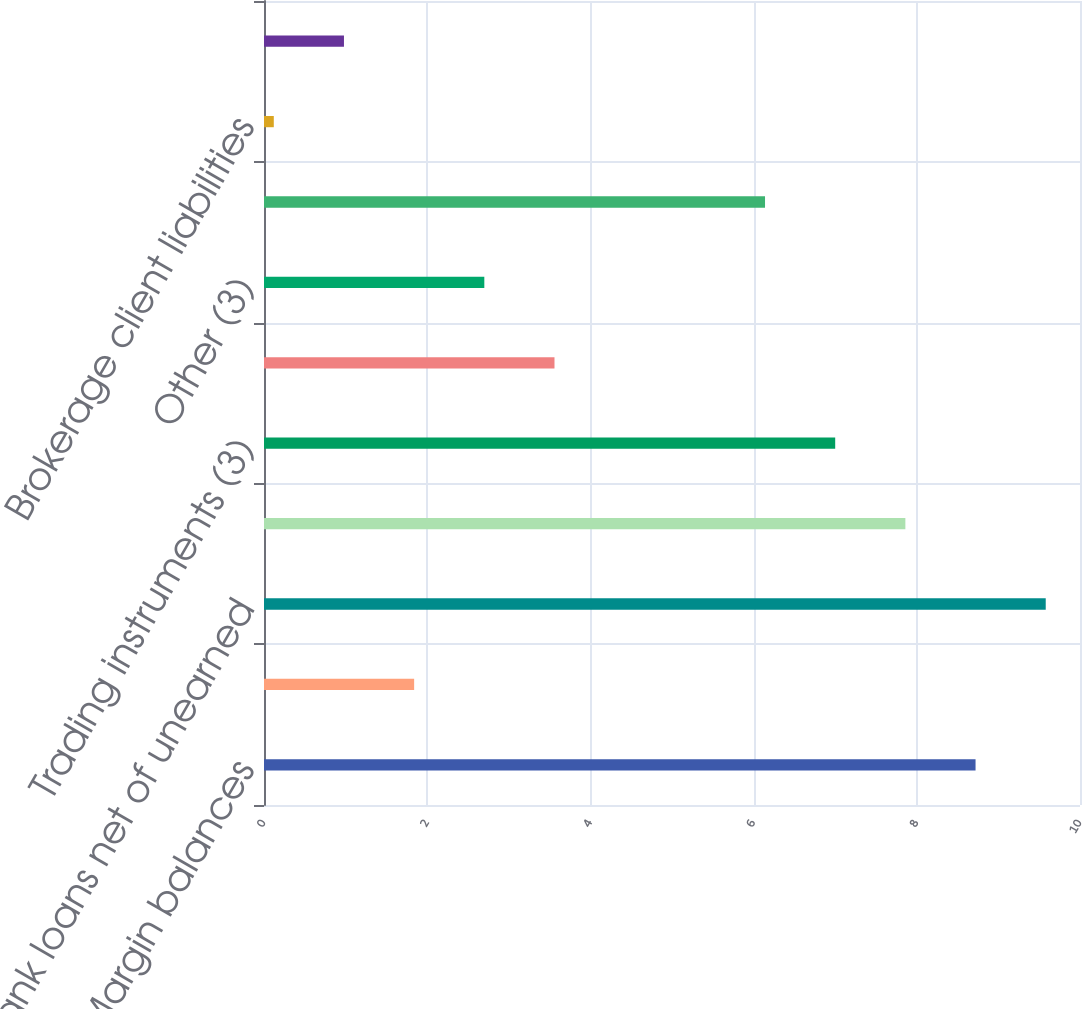Convert chart to OTSL. <chart><loc_0><loc_0><loc_500><loc_500><bar_chart><fcel>Margin balances<fcel>Assets segregated pursuant to<fcel>Bank loans net of unearned<fcel>Available for sale securities<fcel>Trading instruments (3)<fcel>Stock loan<fcel>Other (3)<fcel>Total<fcel>Brokerage client liabilities<fcel>Bank deposits (2)<nl><fcel>8.72<fcel>1.84<fcel>9.58<fcel>7.86<fcel>7<fcel>3.56<fcel>2.7<fcel>6.14<fcel>0.12<fcel>0.98<nl></chart> 